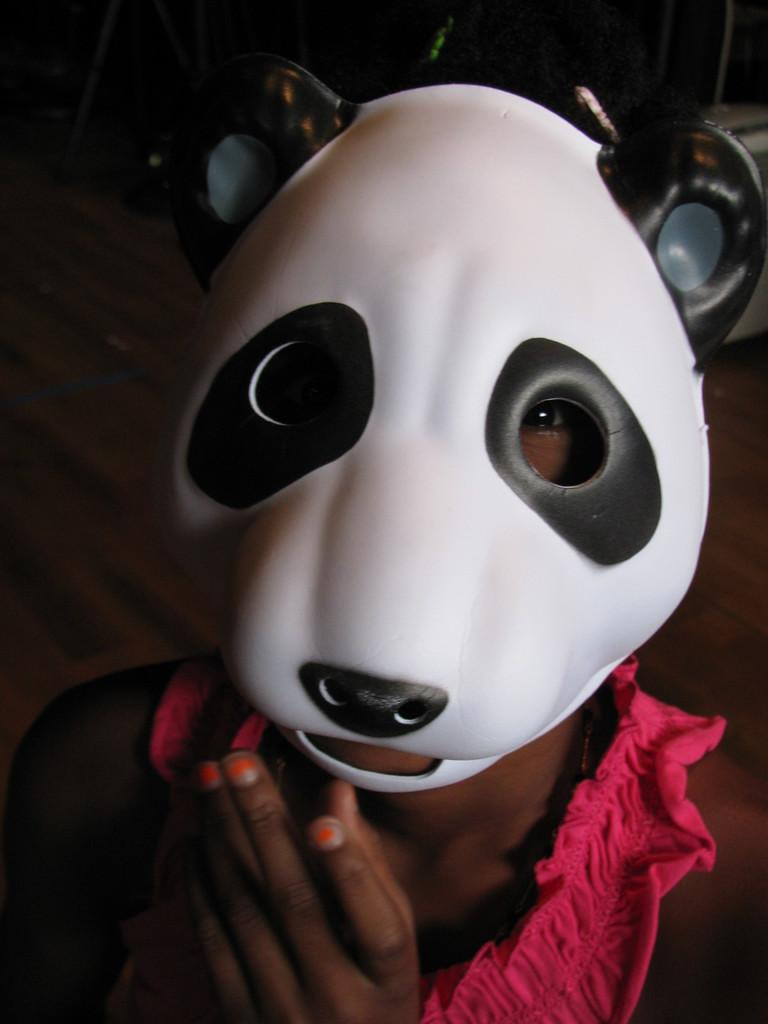Who or what is the main subject in the image? There is a person in the image. Where is the person located in the image? The person is in the center of the image. What is the person wearing on their face? The person is wearing an animal mask. What route does the person take to get to the other side of the image? There is no route or movement in the image; it is a still photograph. 